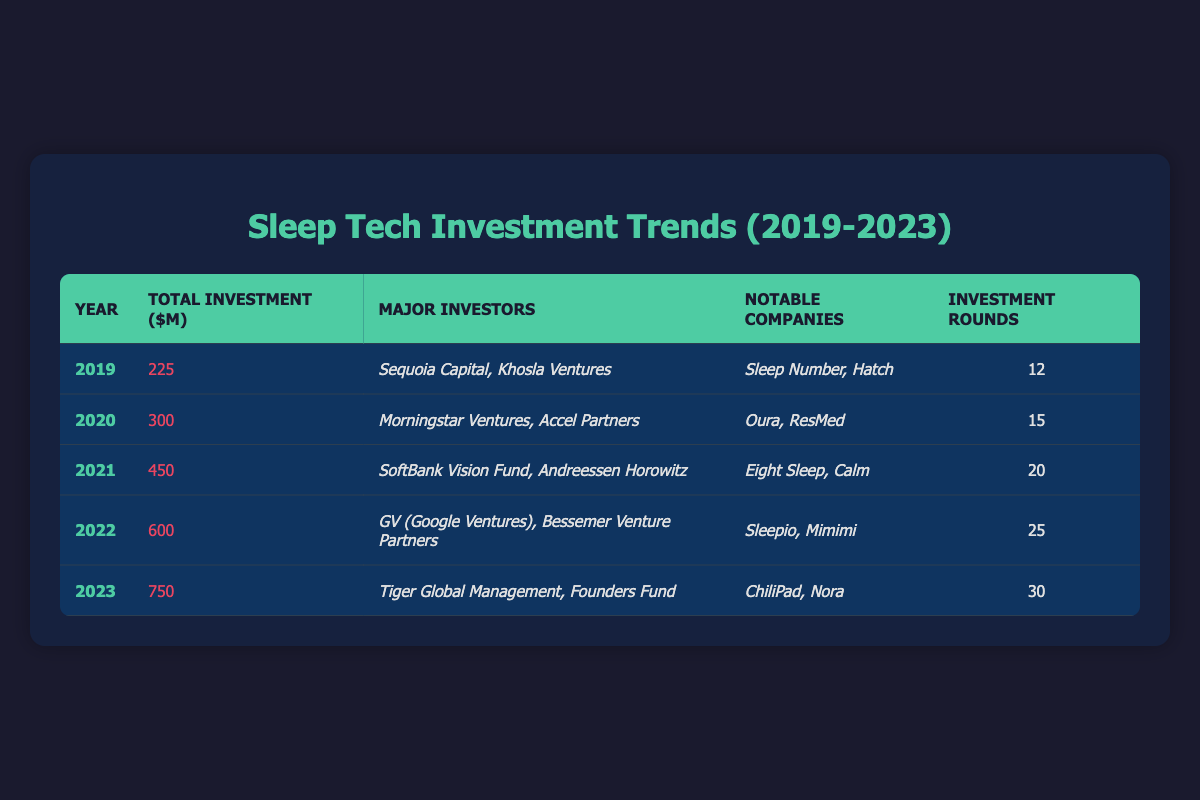What was the total investment in sleep tech in 2020? The table shows that for the year 2020, the total investment was recorded as 300 million dollars.
Answer: 300 million dollars Which major investors participated in the sleep tech industry in 2021? According to the table, the major investors in 2021 were SoftBank Vision Fund and Andreessen Horowitz.
Answer: SoftBank Vision Fund, Andreessen Horowitz How much did the total investment increase from 2019 to 2023? The total investment in 2019 was 225 million dollars, and in 2023 it was 750 million dollars. The increase is calculated as 750 - 225 = 525 million dollars.
Answer: 525 million dollars Was there a year when the total investment in sleep tech exceeded 500 million dollars? Yes, according to the table, the total investment exceeded 500 million dollars in both 2022 and 2023.
Answer: Yes What is the average total investment per year from 2019 to 2023? To find the average, first sum the investments from all years: 225 + 300 + 450 + 600 + 750 = 2325 million dollars. There are 5 years, so the average is 2325 / 5 = 465 million dollars.
Answer: 465 million dollars In which year were the most investment rounds recorded? The table indicates that the year with the most investment rounds was 2023, with a total of 30 rounds.
Answer: 2023 What were the notable companies in the year 2022? The table lists Sleepio and Mimimi as the notable companies in 2022.
Answer: Sleepio, Mimimi Did Tiger Global Management invest in the sleep tech industry in 2023? Yes, according to the table, Tiger Global Management was one of the major investors in 2023.
Answer: Yes Which year saw the highest total investment? The highest total investment was in 2023, with 750 million dollars recorded in that year.
Answer: 2023 